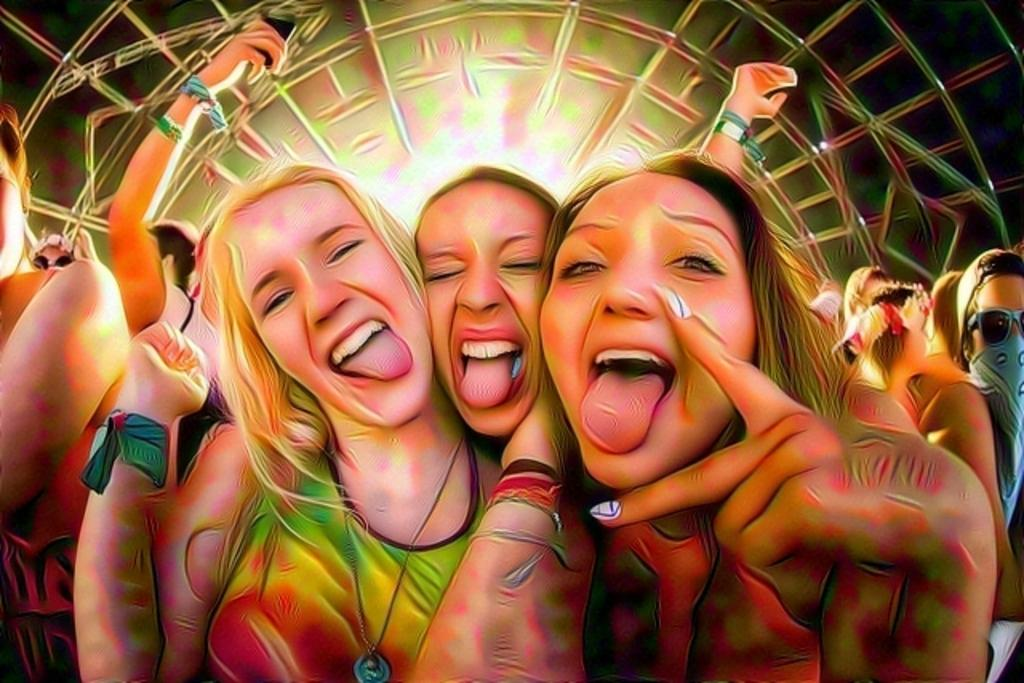How many people are in the image? There is a group of people in the image, but the exact number cannot be determined from the provided facts. What can be seen in the background of the image? There is a truss-like structure in the background of the image. What type of pet is being guided by the group of people in the image? There is no pet present in the image, and therefore no such guiding activity can be observed. 